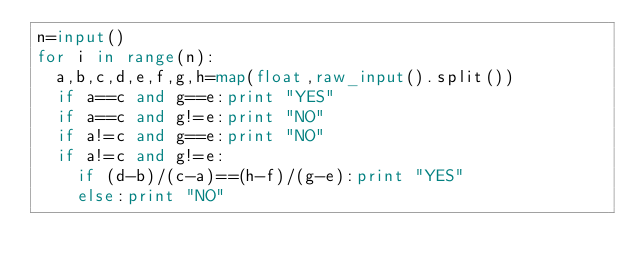<code> <loc_0><loc_0><loc_500><loc_500><_Python_>n=input()
for i in range(n):
	a,b,c,d,e,f,g,h=map(float,raw_input().split())
	if a==c and g==e:print "YES"
	if a==c and g!=e:print "NO"
	if a!=c and g==e:print "NO"
	if a!=c and g!=e:
		if (d-b)/(c-a)==(h-f)/(g-e):print "YES"
		else:print "NO"</code> 